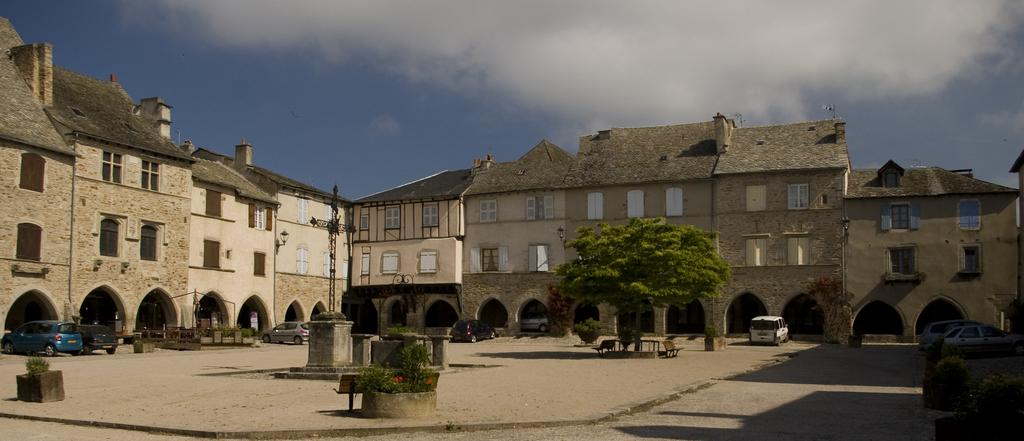What type of structures can be seen in the image? There are buildings in the image. What natural elements are present in the image? There are trees and plants in the image. What type of seating is available in the image? There is a bench in the image. What mode of transportation can be seen in the image? There are cars in the image. What part of the natural environment is visible in the image? The sky is visible in the image. What atmospheric conditions can be observed in the sky? There are clouds in the sky. How many boats are docked near the buildings in the image? There are no boats present in the image; it features buildings, trees, plants, a bench, cars, the sky, and clouds. What type of nerve is responsible for the movement of the clouds in the image? There is no mention of nerves or their functions in the image, as it focuses on the visual elements of the scene. 